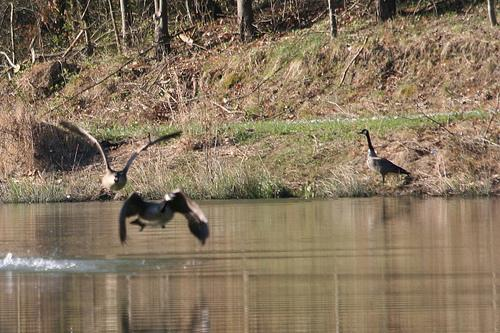These animals have an impressive what?

Choices:
A) stinger
B) quill
C) wingspan
D) tusk wingspan 